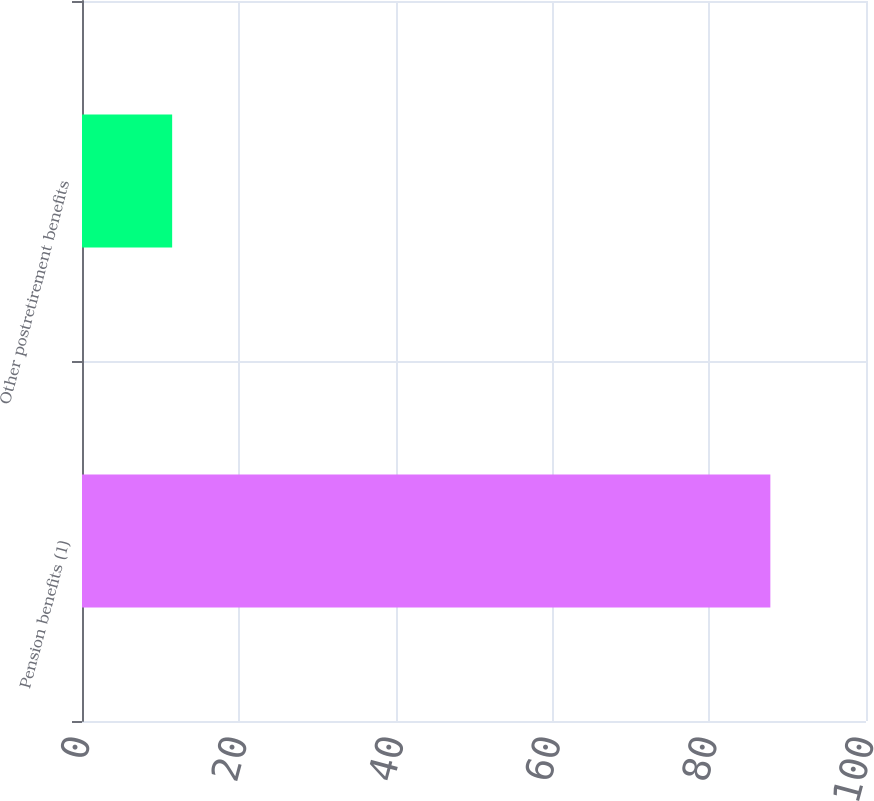Convert chart to OTSL. <chart><loc_0><loc_0><loc_500><loc_500><bar_chart><fcel>Pension benefits (1)<fcel>Other postretirement benefits<nl><fcel>87.8<fcel>11.5<nl></chart> 